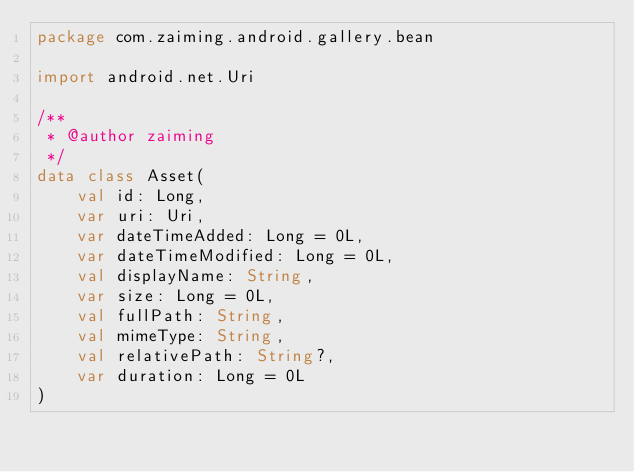Convert code to text. <code><loc_0><loc_0><loc_500><loc_500><_Kotlin_>package com.zaiming.android.gallery.bean

import android.net.Uri

/**
 * @author zaiming
 */
data class Asset(
    val id: Long,
    var uri: Uri,
    var dateTimeAdded: Long = 0L,
    var dateTimeModified: Long = 0L,
    val displayName: String,
    var size: Long = 0L,
    val fullPath: String,
    val mimeType: String,
    val relativePath: String?,
    var duration: Long = 0L
)
</code> 